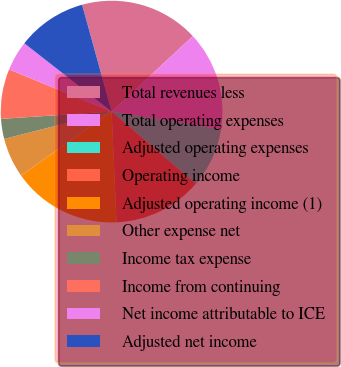<chart> <loc_0><loc_0><loc_500><loc_500><pie_chart><fcel>Total revenues less<fcel>Total operating expenses<fcel>Adjusted operating expenses<fcel>Operating income<fcel>Adjusted operating income (1)<fcel>Other expense net<fcel>Income tax expense<fcel>Income from continuing<fcel>Net income attributable to ICE<fcel>Adjusted net income<nl><fcel>17.37%<fcel>14.48%<fcel>8.7%<fcel>13.03%<fcel>15.92%<fcel>5.81%<fcel>2.92%<fcel>7.25%<fcel>4.36%<fcel>10.14%<nl></chart> 